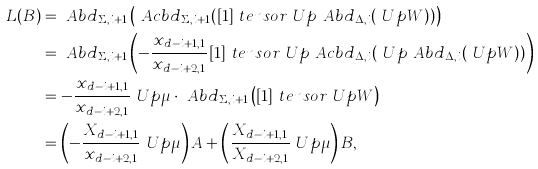Convert formula to latex. <formula><loc_0><loc_0><loc_500><loc_500>L ( B ) & = \ A b d _ { \Sigma , i + 1 } \left ( \ A c b d _ { \Sigma , i + 1 } ( [ 1 ] \ t e n s o r \ U p \ A b d _ { \Delta , i } ( \ U p W ) ) \right ) \\ & = \ A b d _ { \Sigma , i + 1 } \left ( - \frac { x _ { d - i + 1 , 1 } } { x _ { d - i + 2 , 1 } } [ 1 ] \ t e n s o r \ U p \ A c b d _ { \Delta , i } ( \ U p \ A b d _ { \Delta , i } ( \ U p W ) ) \right ) \\ & = - \frac { x _ { d - i + 1 , 1 } } { x _ { d - i + 2 , 1 } } \ U p \mu \cdot \ A b d _ { \Sigma , i + 1 } \left ( [ 1 ] \ t e n s o r \ U p W \right ) \\ & = \left ( - \frac { X _ { d - i + 1 , 1 } } { x _ { d - i + 2 , 1 } } \ U p \mu \right ) A + \left ( \frac { X _ { d - i + 1 , 1 } } { X _ { d - i + 2 , 1 } } \ U p \mu \right ) B ,</formula> 